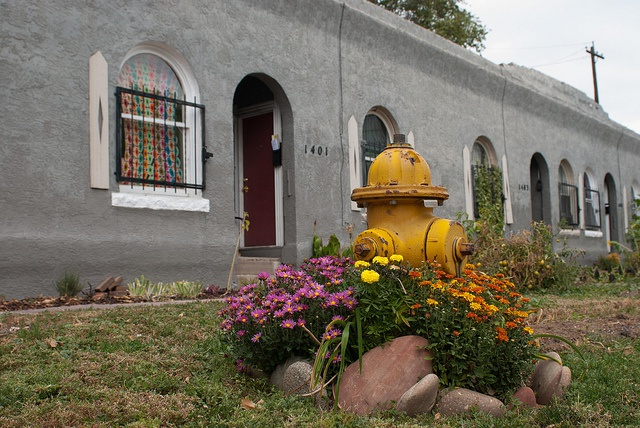Describe the objects in this image and their specific colors. I can see a fire hydrant in gray, olive, orange, and maroon tones in this image. 